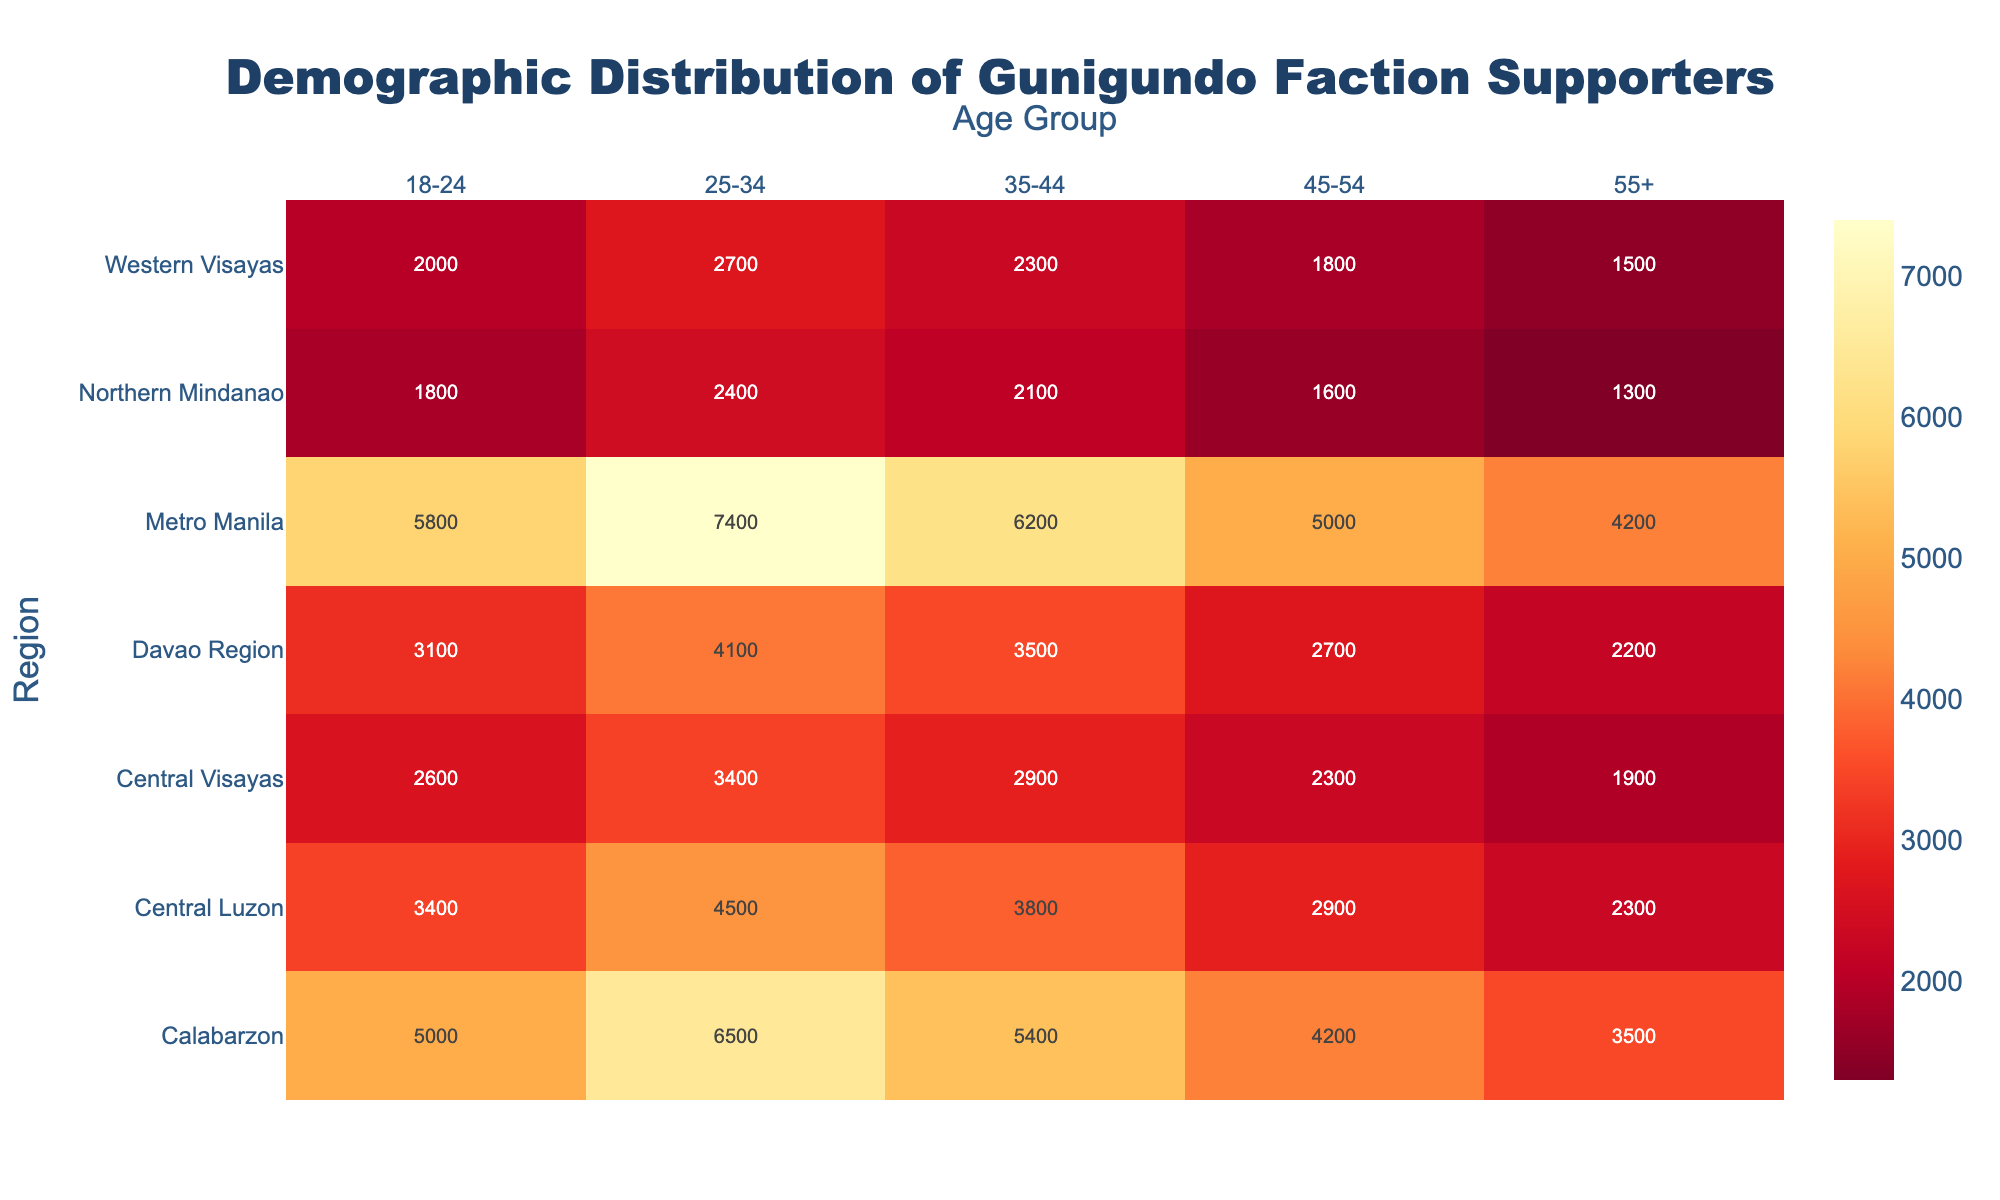What is the title of the figure? The title is centered at the top of the figure. It reads "Demographic Distribution of Gunigundo Faction Supporters".
Answer: Demographic Distribution of Gunigundo Faction Supporters Which age group has the highest supporter count in Metro Manila? Refer to the column for Metro Manila and find the highest value in the row corresponding to age groups. The value 7400 corresponds to the 25-34 age group.
Answer: 25-34 In which region is the 18-24 age group least supportive? Compare the values in the column for the 18-24 age group across all regions. The smallest value (1800) appears in Northern Mindanao.
Answer: Northern Mindanao How many regions are shown in the heatmap? Count the number of unique regions listed along the y-axis of the heatmap. There are 6 regions: Metro Manila, Central Luzon, Calabarzon, Western Visayas, Central Visayas, and Northern Mindanao.
Answer: 6 Which region shows the lowest overall support for the Gunigundo faction when considering all age groups? Sum up the supporter counts across all age groups for each region. Western Visayas has the lowest total support (2000 + 2700 + 2300 + 1800 + 1500 = 10300).
Answer: Western Visayas In Central Luzon, which two age groups together account for the largest number of supporters? Calculate the sum of support counts for every pair of age groups in Central Luzon. The sum of the 18-24 (3400) and 25-34 (4500) age group is the largest: 3400 + 4500 = 7900.
Answer: 18-24 and 25-34 Compare the support of the 55+ age group between Calabarzon and Davao Region. Which region has higher support? Look at the values for the 55+ age group in both Calabarzon (3500) and Davao Region (2200). Calabarzon has a higher supporter count.
Answer: Calabarzon What is the average number of supporters in the 35-44 age group across all regions? Add the support counts of the 35-44 age group across all regions and divide by the number of regions: (6200 + 3800 + 5400 + 2300 + 2900 + 3500 + 2100) / 7 = 3600
Answer: 3600 Which region has the most supporters in the 45-54 age group? Compare the values for the 45-54 age group across all regions. The highest value (5000) is in Metro Manila.
Answer: Metro Manila 